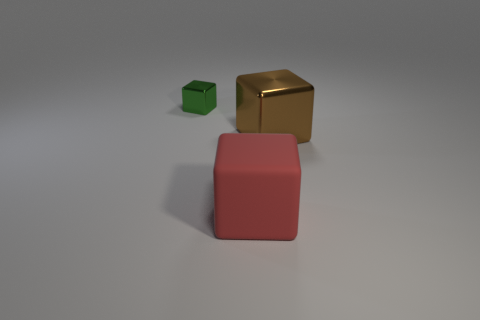Add 2 large matte balls. How many objects exist? 5 Add 1 matte balls. How many matte balls exist? 1 Subtract 0 purple spheres. How many objects are left? 3 Subtract all big red rubber blocks. Subtract all small green metallic cubes. How many objects are left? 1 Add 3 matte things. How many matte things are left? 4 